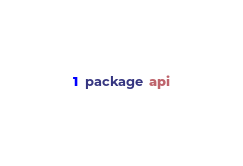Convert code to text. <code><loc_0><loc_0><loc_500><loc_500><_Go_>package api
</code> 